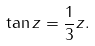<formula> <loc_0><loc_0><loc_500><loc_500>\tan z = \frac { 1 } { 3 } z .</formula> 